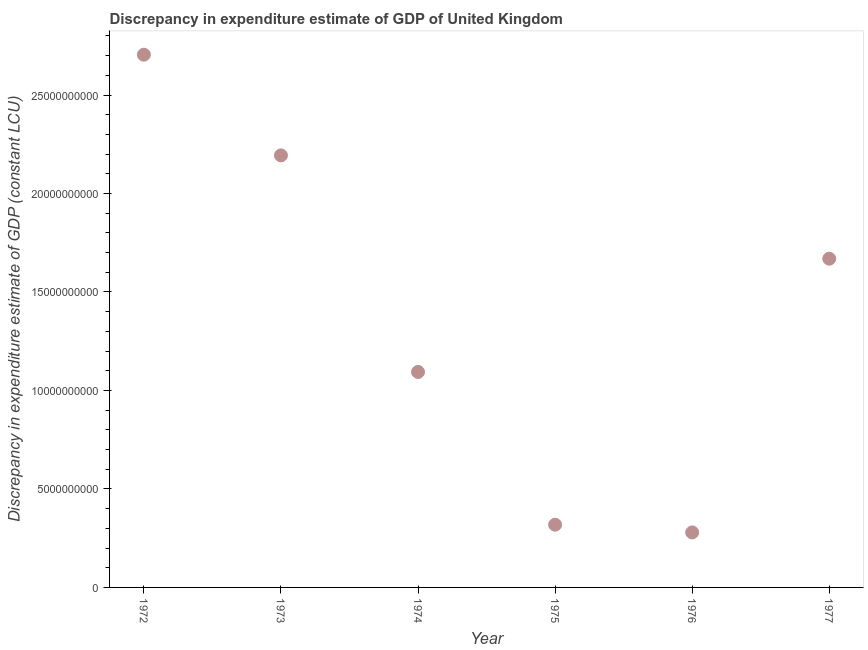What is the discrepancy in expenditure estimate of gdp in 1974?
Provide a succinct answer. 1.09e+1. Across all years, what is the maximum discrepancy in expenditure estimate of gdp?
Provide a short and direct response. 2.70e+1. Across all years, what is the minimum discrepancy in expenditure estimate of gdp?
Offer a terse response. 2.79e+09. In which year was the discrepancy in expenditure estimate of gdp minimum?
Ensure brevity in your answer.  1976. What is the sum of the discrepancy in expenditure estimate of gdp?
Provide a succinct answer. 8.26e+1. What is the difference between the discrepancy in expenditure estimate of gdp in 1972 and 1975?
Your answer should be compact. 2.39e+1. What is the average discrepancy in expenditure estimate of gdp per year?
Your answer should be compact. 1.38e+1. What is the median discrepancy in expenditure estimate of gdp?
Offer a very short reply. 1.38e+1. What is the ratio of the discrepancy in expenditure estimate of gdp in 1972 to that in 1975?
Give a very brief answer. 8.49. Is the difference between the discrepancy in expenditure estimate of gdp in 1975 and 1977 greater than the difference between any two years?
Offer a terse response. No. What is the difference between the highest and the second highest discrepancy in expenditure estimate of gdp?
Your answer should be compact. 5.11e+09. What is the difference between the highest and the lowest discrepancy in expenditure estimate of gdp?
Provide a short and direct response. 2.43e+1. In how many years, is the discrepancy in expenditure estimate of gdp greater than the average discrepancy in expenditure estimate of gdp taken over all years?
Make the answer very short. 3. Does the discrepancy in expenditure estimate of gdp monotonically increase over the years?
Your answer should be very brief. No. How many dotlines are there?
Give a very brief answer. 1. How many years are there in the graph?
Give a very brief answer. 6. Are the values on the major ticks of Y-axis written in scientific E-notation?
Ensure brevity in your answer.  No. Does the graph contain grids?
Provide a succinct answer. No. What is the title of the graph?
Your response must be concise. Discrepancy in expenditure estimate of GDP of United Kingdom. What is the label or title of the X-axis?
Provide a short and direct response. Year. What is the label or title of the Y-axis?
Give a very brief answer. Discrepancy in expenditure estimate of GDP (constant LCU). What is the Discrepancy in expenditure estimate of GDP (constant LCU) in 1972?
Offer a very short reply. 2.70e+1. What is the Discrepancy in expenditure estimate of GDP (constant LCU) in 1973?
Provide a succinct answer. 2.19e+1. What is the Discrepancy in expenditure estimate of GDP (constant LCU) in 1974?
Your answer should be compact. 1.09e+1. What is the Discrepancy in expenditure estimate of GDP (constant LCU) in 1975?
Offer a very short reply. 3.18e+09. What is the Discrepancy in expenditure estimate of GDP (constant LCU) in 1976?
Offer a very short reply. 2.79e+09. What is the Discrepancy in expenditure estimate of GDP (constant LCU) in 1977?
Your response must be concise. 1.67e+1. What is the difference between the Discrepancy in expenditure estimate of GDP (constant LCU) in 1972 and 1973?
Keep it short and to the point. 5.11e+09. What is the difference between the Discrepancy in expenditure estimate of GDP (constant LCU) in 1972 and 1974?
Offer a very short reply. 1.61e+1. What is the difference between the Discrepancy in expenditure estimate of GDP (constant LCU) in 1972 and 1975?
Provide a succinct answer. 2.39e+1. What is the difference between the Discrepancy in expenditure estimate of GDP (constant LCU) in 1972 and 1976?
Keep it short and to the point. 2.43e+1. What is the difference between the Discrepancy in expenditure estimate of GDP (constant LCU) in 1972 and 1977?
Offer a very short reply. 1.04e+1. What is the difference between the Discrepancy in expenditure estimate of GDP (constant LCU) in 1973 and 1974?
Offer a very short reply. 1.10e+1. What is the difference between the Discrepancy in expenditure estimate of GDP (constant LCU) in 1973 and 1975?
Keep it short and to the point. 1.88e+1. What is the difference between the Discrepancy in expenditure estimate of GDP (constant LCU) in 1973 and 1976?
Keep it short and to the point. 1.91e+1. What is the difference between the Discrepancy in expenditure estimate of GDP (constant LCU) in 1973 and 1977?
Your answer should be very brief. 5.25e+09. What is the difference between the Discrepancy in expenditure estimate of GDP (constant LCU) in 1974 and 1975?
Make the answer very short. 7.76e+09. What is the difference between the Discrepancy in expenditure estimate of GDP (constant LCU) in 1974 and 1976?
Your answer should be very brief. 8.15e+09. What is the difference between the Discrepancy in expenditure estimate of GDP (constant LCU) in 1974 and 1977?
Provide a succinct answer. -5.75e+09. What is the difference between the Discrepancy in expenditure estimate of GDP (constant LCU) in 1975 and 1976?
Your answer should be very brief. 3.92e+08. What is the difference between the Discrepancy in expenditure estimate of GDP (constant LCU) in 1975 and 1977?
Your answer should be very brief. -1.35e+1. What is the difference between the Discrepancy in expenditure estimate of GDP (constant LCU) in 1976 and 1977?
Your response must be concise. -1.39e+1. What is the ratio of the Discrepancy in expenditure estimate of GDP (constant LCU) in 1972 to that in 1973?
Make the answer very short. 1.23. What is the ratio of the Discrepancy in expenditure estimate of GDP (constant LCU) in 1972 to that in 1974?
Ensure brevity in your answer.  2.47. What is the ratio of the Discrepancy in expenditure estimate of GDP (constant LCU) in 1972 to that in 1975?
Your answer should be very brief. 8.49. What is the ratio of the Discrepancy in expenditure estimate of GDP (constant LCU) in 1972 to that in 1976?
Your answer should be compact. 9.69. What is the ratio of the Discrepancy in expenditure estimate of GDP (constant LCU) in 1972 to that in 1977?
Make the answer very short. 1.62. What is the ratio of the Discrepancy in expenditure estimate of GDP (constant LCU) in 1973 to that in 1974?
Your answer should be compact. 2. What is the ratio of the Discrepancy in expenditure estimate of GDP (constant LCU) in 1973 to that in 1975?
Make the answer very short. 6.89. What is the ratio of the Discrepancy in expenditure estimate of GDP (constant LCU) in 1973 to that in 1976?
Make the answer very short. 7.85. What is the ratio of the Discrepancy in expenditure estimate of GDP (constant LCU) in 1973 to that in 1977?
Your answer should be very brief. 1.31. What is the ratio of the Discrepancy in expenditure estimate of GDP (constant LCU) in 1974 to that in 1975?
Make the answer very short. 3.44. What is the ratio of the Discrepancy in expenditure estimate of GDP (constant LCU) in 1974 to that in 1976?
Provide a short and direct response. 3.92. What is the ratio of the Discrepancy in expenditure estimate of GDP (constant LCU) in 1974 to that in 1977?
Make the answer very short. 0.66. What is the ratio of the Discrepancy in expenditure estimate of GDP (constant LCU) in 1975 to that in 1976?
Keep it short and to the point. 1.14. What is the ratio of the Discrepancy in expenditure estimate of GDP (constant LCU) in 1975 to that in 1977?
Your answer should be very brief. 0.19. What is the ratio of the Discrepancy in expenditure estimate of GDP (constant LCU) in 1976 to that in 1977?
Make the answer very short. 0.17. 